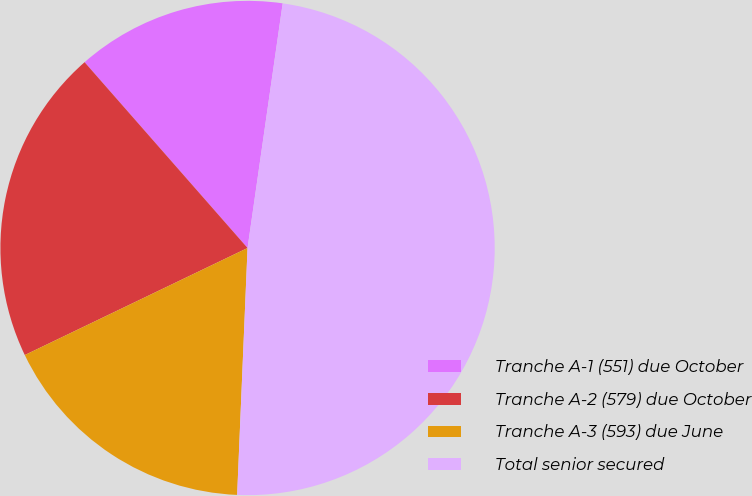Convert chart to OTSL. <chart><loc_0><loc_0><loc_500><loc_500><pie_chart><fcel>Tranche A-1 (551) due October<fcel>Tranche A-2 (579) due October<fcel>Tranche A-3 (593) due June<fcel>Total senior secured<nl><fcel>13.73%<fcel>20.67%<fcel>17.2%<fcel>48.4%<nl></chart> 